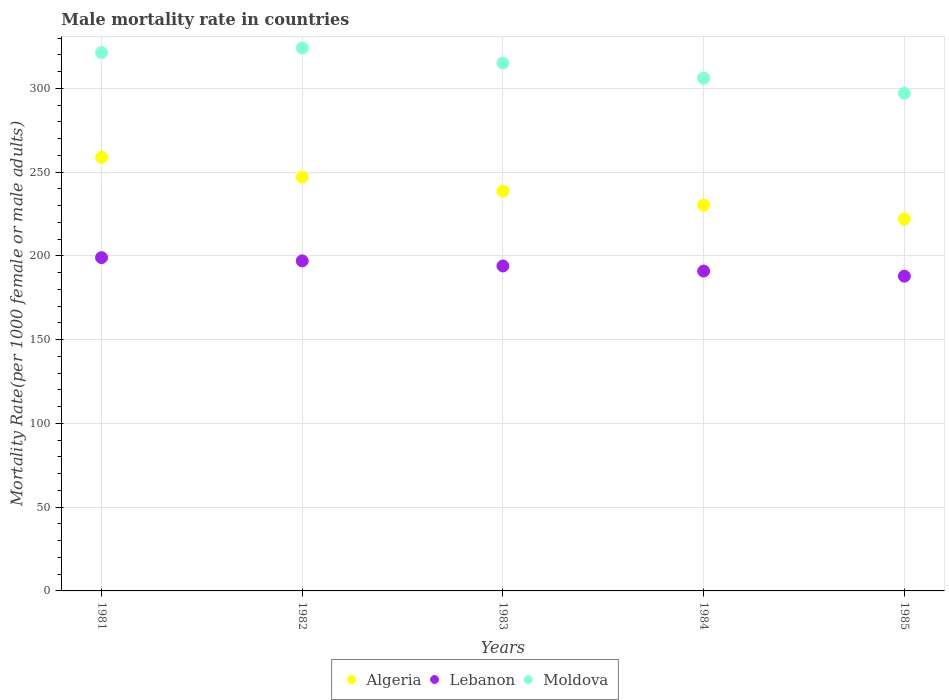How many different coloured dotlines are there?
Make the answer very short. 3. What is the male mortality rate in Moldova in 1983?
Your response must be concise. 315.12. Across all years, what is the maximum male mortality rate in Moldova?
Provide a succinct answer. 324.11. Across all years, what is the minimum male mortality rate in Algeria?
Your answer should be compact. 221.99. In which year was the male mortality rate in Moldova minimum?
Offer a terse response. 1985. What is the total male mortality rate in Algeria in the graph?
Keep it short and to the point. 1196.84. What is the difference between the male mortality rate in Algeria in 1982 and that in 1983?
Your response must be concise. 8.34. What is the difference between the male mortality rate in Algeria in 1985 and the male mortality rate in Moldova in 1981?
Offer a terse response. -99.38. What is the average male mortality rate in Algeria per year?
Your response must be concise. 239.37. In the year 1983, what is the difference between the male mortality rate in Moldova and male mortality rate in Lebanon?
Ensure brevity in your answer.  121.14. What is the ratio of the male mortality rate in Algeria in 1983 to that in 1984?
Your answer should be compact. 1.04. Is the difference between the male mortality rate in Moldova in 1984 and 1985 greater than the difference between the male mortality rate in Lebanon in 1984 and 1985?
Give a very brief answer. Yes. What is the difference between the highest and the second highest male mortality rate in Lebanon?
Offer a very short reply. 1.94. What is the difference between the highest and the lowest male mortality rate in Algeria?
Provide a succinct answer. 36.84. In how many years, is the male mortality rate in Moldova greater than the average male mortality rate in Moldova taken over all years?
Your answer should be compact. 3. Is the sum of the male mortality rate in Algeria in 1981 and 1984 greater than the maximum male mortality rate in Moldova across all years?
Provide a short and direct response. Yes. Is the male mortality rate in Moldova strictly greater than the male mortality rate in Algeria over the years?
Provide a succinct answer. Yes. How many years are there in the graph?
Your response must be concise. 5. Are the values on the major ticks of Y-axis written in scientific E-notation?
Provide a succinct answer. No. Does the graph contain grids?
Offer a terse response. Yes. What is the title of the graph?
Ensure brevity in your answer.  Male mortality rate in countries. Does "Timor-Leste" appear as one of the legend labels in the graph?
Provide a short and direct response. No. What is the label or title of the Y-axis?
Your answer should be very brief. Mortality Rate(per 1000 female or male adults). What is the Mortality Rate(per 1000 female or male adults) of Algeria in 1981?
Offer a terse response. 258.83. What is the Mortality Rate(per 1000 female or male adults) in Lebanon in 1981?
Keep it short and to the point. 198.96. What is the Mortality Rate(per 1000 female or male adults) of Moldova in 1981?
Offer a terse response. 321.38. What is the Mortality Rate(per 1000 female or male adults) of Algeria in 1982?
Give a very brief answer. 247.01. What is the Mortality Rate(per 1000 female or male adults) in Lebanon in 1982?
Offer a very short reply. 197.02. What is the Mortality Rate(per 1000 female or male adults) in Moldova in 1982?
Your response must be concise. 324.11. What is the Mortality Rate(per 1000 female or male adults) of Algeria in 1983?
Provide a short and direct response. 238.67. What is the Mortality Rate(per 1000 female or male adults) in Lebanon in 1983?
Make the answer very short. 193.98. What is the Mortality Rate(per 1000 female or male adults) of Moldova in 1983?
Ensure brevity in your answer.  315.12. What is the Mortality Rate(per 1000 female or male adults) of Algeria in 1984?
Ensure brevity in your answer.  230.33. What is the Mortality Rate(per 1000 female or male adults) of Lebanon in 1984?
Provide a short and direct response. 190.93. What is the Mortality Rate(per 1000 female or male adults) in Moldova in 1984?
Ensure brevity in your answer.  306.13. What is the Mortality Rate(per 1000 female or male adults) in Algeria in 1985?
Your response must be concise. 221.99. What is the Mortality Rate(per 1000 female or male adults) in Lebanon in 1985?
Your response must be concise. 187.89. What is the Mortality Rate(per 1000 female or male adults) in Moldova in 1985?
Your response must be concise. 297.14. Across all years, what is the maximum Mortality Rate(per 1000 female or male adults) in Algeria?
Ensure brevity in your answer.  258.83. Across all years, what is the maximum Mortality Rate(per 1000 female or male adults) in Lebanon?
Your response must be concise. 198.96. Across all years, what is the maximum Mortality Rate(per 1000 female or male adults) of Moldova?
Offer a terse response. 324.11. Across all years, what is the minimum Mortality Rate(per 1000 female or male adults) of Algeria?
Your answer should be very brief. 221.99. Across all years, what is the minimum Mortality Rate(per 1000 female or male adults) of Lebanon?
Provide a succinct answer. 187.89. Across all years, what is the minimum Mortality Rate(per 1000 female or male adults) of Moldova?
Ensure brevity in your answer.  297.14. What is the total Mortality Rate(per 1000 female or male adults) of Algeria in the graph?
Keep it short and to the point. 1196.84. What is the total Mortality Rate(per 1000 female or male adults) of Lebanon in the graph?
Keep it short and to the point. 968.79. What is the total Mortality Rate(per 1000 female or male adults) of Moldova in the graph?
Offer a very short reply. 1563.88. What is the difference between the Mortality Rate(per 1000 female or male adults) of Algeria in 1981 and that in 1982?
Make the answer very short. 11.82. What is the difference between the Mortality Rate(per 1000 female or male adults) of Lebanon in 1981 and that in 1982?
Your response must be concise. 1.94. What is the difference between the Mortality Rate(per 1000 female or male adults) in Moldova in 1981 and that in 1982?
Your answer should be compact. -2.74. What is the difference between the Mortality Rate(per 1000 female or male adults) in Algeria in 1981 and that in 1983?
Your answer should be compact. 20.16. What is the difference between the Mortality Rate(per 1000 female or male adults) of Lebanon in 1981 and that in 1983?
Your answer should be compact. 4.99. What is the difference between the Mortality Rate(per 1000 female or male adults) in Moldova in 1981 and that in 1983?
Make the answer very short. 6.26. What is the difference between the Mortality Rate(per 1000 female or male adults) of Algeria in 1981 and that in 1984?
Offer a very short reply. 28.5. What is the difference between the Mortality Rate(per 1000 female or male adults) of Lebanon in 1981 and that in 1984?
Ensure brevity in your answer.  8.03. What is the difference between the Mortality Rate(per 1000 female or male adults) in Moldova in 1981 and that in 1984?
Make the answer very short. 15.25. What is the difference between the Mortality Rate(per 1000 female or male adults) of Algeria in 1981 and that in 1985?
Provide a short and direct response. 36.84. What is the difference between the Mortality Rate(per 1000 female or male adults) of Lebanon in 1981 and that in 1985?
Your answer should be compact. 11.07. What is the difference between the Mortality Rate(per 1000 female or male adults) of Moldova in 1981 and that in 1985?
Offer a very short reply. 24.24. What is the difference between the Mortality Rate(per 1000 female or male adults) in Algeria in 1982 and that in 1983?
Provide a succinct answer. 8.34. What is the difference between the Mortality Rate(per 1000 female or male adults) in Lebanon in 1982 and that in 1983?
Your response must be concise. 3.04. What is the difference between the Mortality Rate(per 1000 female or male adults) of Moldova in 1982 and that in 1983?
Give a very brief answer. 8.99. What is the difference between the Mortality Rate(per 1000 female or male adults) of Algeria in 1982 and that in 1984?
Provide a short and direct response. 16.68. What is the difference between the Mortality Rate(per 1000 female or male adults) in Lebanon in 1982 and that in 1984?
Offer a very short reply. 6.09. What is the difference between the Mortality Rate(per 1000 female or male adults) in Moldova in 1982 and that in 1984?
Offer a very short reply. 17.98. What is the difference between the Mortality Rate(per 1000 female or male adults) of Algeria in 1982 and that in 1985?
Offer a very short reply. 25.02. What is the difference between the Mortality Rate(per 1000 female or male adults) in Lebanon in 1982 and that in 1985?
Your answer should be compact. 9.13. What is the difference between the Mortality Rate(per 1000 female or male adults) of Moldova in 1982 and that in 1985?
Offer a very short reply. 26.97. What is the difference between the Mortality Rate(per 1000 female or male adults) in Algeria in 1983 and that in 1984?
Keep it short and to the point. 8.34. What is the difference between the Mortality Rate(per 1000 female or male adults) in Lebanon in 1983 and that in 1984?
Offer a very short reply. 3.04. What is the difference between the Mortality Rate(per 1000 female or male adults) in Moldova in 1983 and that in 1984?
Provide a short and direct response. 8.99. What is the difference between the Mortality Rate(per 1000 female or male adults) of Algeria in 1983 and that in 1985?
Offer a terse response. 16.68. What is the difference between the Mortality Rate(per 1000 female or male adults) in Lebanon in 1983 and that in 1985?
Your answer should be very brief. 6.09. What is the difference between the Mortality Rate(per 1000 female or male adults) in Moldova in 1983 and that in 1985?
Your answer should be compact. 17.98. What is the difference between the Mortality Rate(per 1000 female or male adults) of Algeria in 1984 and that in 1985?
Your answer should be very brief. 8.34. What is the difference between the Mortality Rate(per 1000 female or male adults) in Lebanon in 1984 and that in 1985?
Give a very brief answer. 3.04. What is the difference between the Mortality Rate(per 1000 female or male adults) of Moldova in 1984 and that in 1985?
Ensure brevity in your answer.  8.99. What is the difference between the Mortality Rate(per 1000 female or male adults) of Algeria in 1981 and the Mortality Rate(per 1000 female or male adults) of Lebanon in 1982?
Your response must be concise. 61.81. What is the difference between the Mortality Rate(per 1000 female or male adults) of Algeria in 1981 and the Mortality Rate(per 1000 female or male adults) of Moldova in 1982?
Your answer should be very brief. -65.28. What is the difference between the Mortality Rate(per 1000 female or male adults) in Lebanon in 1981 and the Mortality Rate(per 1000 female or male adults) in Moldova in 1982?
Your answer should be compact. -125.15. What is the difference between the Mortality Rate(per 1000 female or male adults) in Algeria in 1981 and the Mortality Rate(per 1000 female or male adults) in Lebanon in 1983?
Make the answer very short. 64.86. What is the difference between the Mortality Rate(per 1000 female or male adults) in Algeria in 1981 and the Mortality Rate(per 1000 female or male adults) in Moldova in 1983?
Provide a succinct answer. -56.29. What is the difference between the Mortality Rate(per 1000 female or male adults) of Lebanon in 1981 and the Mortality Rate(per 1000 female or male adults) of Moldova in 1983?
Give a very brief answer. -116.16. What is the difference between the Mortality Rate(per 1000 female or male adults) in Algeria in 1981 and the Mortality Rate(per 1000 female or male adults) in Lebanon in 1984?
Provide a succinct answer. 67.9. What is the difference between the Mortality Rate(per 1000 female or male adults) of Algeria in 1981 and the Mortality Rate(per 1000 female or male adults) of Moldova in 1984?
Ensure brevity in your answer.  -47.3. What is the difference between the Mortality Rate(per 1000 female or male adults) of Lebanon in 1981 and the Mortality Rate(per 1000 female or male adults) of Moldova in 1984?
Your answer should be compact. -107.17. What is the difference between the Mortality Rate(per 1000 female or male adults) in Algeria in 1981 and the Mortality Rate(per 1000 female or male adults) in Lebanon in 1985?
Your answer should be very brief. 70.94. What is the difference between the Mortality Rate(per 1000 female or male adults) in Algeria in 1981 and the Mortality Rate(per 1000 female or male adults) in Moldova in 1985?
Provide a succinct answer. -38.3. What is the difference between the Mortality Rate(per 1000 female or male adults) in Lebanon in 1981 and the Mortality Rate(per 1000 female or male adults) in Moldova in 1985?
Ensure brevity in your answer.  -98.17. What is the difference between the Mortality Rate(per 1000 female or male adults) of Algeria in 1982 and the Mortality Rate(per 1000 female or male adults) of Lebanon in 1983?
Ensure brevity in your answer.  53.03. What is the difference between the Mortality Rate(per 1000 female or male adults) of Algeria in 1982 and the Mortality Rate(per 1000 female or male adults) of Moldova in 1983?
Provide a short and direct response. -68.11. What is the difference between the Mortality Rate(per 1000 female or male adults) of Lebanon in 1982 and the Mortality Rate(per 1000 female or male adults) of Moldova in 1983?
Provide a short and direct response. -118.1. What is the difference between the Mortality Rate(per 1000 female or male adults) of Algeria in 1982 and the Mortality Rate(per 1000 female or male adults) of Lebanon in 1984?
Give a very brief answer. 56.07. What is the difference between the Mortality Rate(per 1000 female or male adults) of Algeria in 1982 and the Mortality Rate(per 1000 female or male adults) of Moldova in 1984?
Ensure brevity in your answer.  -59.12. What is the difference between the Mortality Rate(per 1000 female or male adults) of Lebanon in 1982 and the Mortality Rate(per 1000 female or male adults) of Moldova in 1984?
Ensure brevity in your answer.  -109.11. What is the difference between the Mortality Rate(per 1000 female or male adults) of Algeria in 1982 and the Mortality Rate(per 1000 female or male adults) of Lebanon in 1985?
Make the answer very short. 59.12. What is the difference between the Mortality Rate(per 1000 female or male adults) in Algeria in 1982 and the Mortality Rate(per 1000 female or male adults) in Moldova in 1985?
Your response must be concise. -50.13. What is the difference between the Mortality Rate(per 1000 female or male adults) of Lebanon in 1982 and the Mortality Rate(per 1000 female or male adults) of Moldova in 1985?
Provide a short and direct response. -100.12. What is the difference between the Mortality Rate(per 1000 female or male adults) of Algeria in 1983 and the Mortality Rate(per 1000 female or male adults) of Lebanon in 1984?
Ensure brevity in your answer.  47.74. What is the difference between the Mortality Rate(per 1000 female or male adults) of Algeria in 1983 and the Mortality Rate(per 1000 female or male adults) of Moldova in 1984?
Your answer should be compact. -67.46. What is the difference between the Mortality Rate(per 1000 female or male adults) of Lebanon in 1983 and the Mortality Rate(per 1000 female or male adults) of Moldova in 1984?
Make the answer very short. -112.15. What is the difference between the Mortality Rate(per 1000 female or male adults) of Algeria in 1983 and the Mortality Rate(per 1000 female or male adults) of Lebanon in 1985?
Your response must be concise. 50.78. What is the difference between the Mortality Rate(per 1000 female or male adults) in Algeria in 1983 and the Mortality Rate(per 1000 female or male adults) in Moldova in 1985?
Ensure brevity in your answer.  -58.47. What is the difference between the Mortality Rate(per 1000 female or male adults) of Lebanon in 1983 and the Mortality Rate(per 1000 female or male adults) of Moldova in 1985?
Offer a terse response. -103.16. What is the difference between the Mortality Rate(per 1000 female or male adults) in Algeria in 1984 and the Mortality Rate(per 1000 female or male adults) in Lebanon in 1985?
Provide a short and direct response. 42.44. What is the difference between the Mortality Rate(per 1000 female or male adults) in Algeria in 1984 and the Mortality Rate(per 1000 female or male adults) in Moldova in 1985?
Your answer should be compact. -66.81. What is the difference between the Mortality Rate(per 1000 female or male adults) in Lebanon in 1984 and the Mortality Rate(per 1000 female or male adults) in Moldova in 1985?
Give a very brief answer. -106.2. What is the average Mortality Rate(per 1000 female or male adults) of Algeria per year?
Your answer should be compact. 239.37. What is the average Mortality Rate(per 1000 female or male adults) of Lebanon per year?
Provide a short and direct response. 193.76. What is the average Mortality Rate(per 1000 female or male adults) of Moldova per year?
Provide a short and direct response. 312.78. In the year 1981, what is the difference between the Mortality Rate(per 1000 female or male adults) of Algeria and Mortality Rate(per 1000 female or male adults) of Lebanon?
Provide a short and direct response. 59.87. In the year 1981, what is the difference between the Mortality Rate(per 1000 female or male adults) of Algeria and Mortality Rate(per 1000 female or male adults) of Moldova?
Ensure brevity in your answer.  -62.54. In the year 1981, what is the difference between the Mortality Rate(per 1000 female or male adults) of Lebanon and Mortality Rate(per 1000 female or male adults) of Moldova?
Keep it short and to the point. -122.41. In the year 1982, what is the difference between the Mortality Rate(per 1000 female or male adults) of Algeria and Mortality Rate(per 1000 female or male adults) of Lebanon?
Provide a succinct answer. 49.99. In the year 1982, what is the difference between the Mortality Rate(per 1000 female or male adults) in Algeria and Mortality Rate(per 1000 female or male adults) in Moldova?
Your answer should be very brief. -77.1. In the year 1982, what is the difference between the Mortality Rate(per 1000 female or male adults) of Lebanon and Mortality Rate(per 1000 female or male adults) of Moldova?
Provide a short and direct response. -127.09. In the year 1983, what is the difference between the Mortality Rate(per 1000 female or male adults) of Algeria and Mortality Rate(per 1000 female or male adults) of Lebanon?
Your answer should be very brief. 44.69. In the year 1983, what is the difference between the Mortality Rate(per 1000 female or male adults) in Algeria and Mortality Rate(per 1000 female or male adults) in Moldova?
Offer a very short reply. -76.45. In the year 1983, what is the difference between the Mortality Rate(per 1000 female or male adults) in Lebanon and Mortality Rate(per 1000 female or male adults) in Moldova?
Keep it short and to the point. -121.14. In the year 1984, what is the difference between the Mortality Rate(per 1000 female or male adults) in Algeria and Mortality Rate(per 1000 female or male adults) in Lebanon?
Offer a very short reply. 39.4. In the year 1984, what is the difference between the Mortality Rate(per 1000 female or male adults) in Algeria and Mortality Rate(per 1000 female or male adults) in Moldova?
Provide a succinct answer. -75.8. In the year 1984, what is the difference between the Mortality Rate(per 1000 female or male adults) of Lebanon and Mortality Rate(per 1000 female or male adults) of Moldova?
Give a very brief answer. -115.2. In the year 1985, what is the difference between the Mortality Rate(per 1000 female or male adults) in Algeria and Mortality Rate(per 1000 female or male adults) in Lebanon?
Keep it short and to the point. 34.1. In the year 1985, what is the difference between the Mortality Rate(per 1000 female or male adults) in Algeria and Mortality Rate(per 1000 female or male adults) in Moldova?
Ensure brevity in your answer.  -75.15. In the year 1985, what is the difference between the Mortality Rate(per 1000 female or male adults) in Lebanon and Mortality Rate(per 1000 female or male adults) in Moldova?
Give a very brief answer. -109.25. What is the ratio of the Mortality Rate(per 1000 female or male adults) of Algeria in 1981 to that in 1982?
Provide a short and direct response. 1.05. What is the ratio of the Mortality Rate(per 1000 female or male adults) in Lebanon in 1981 to that in 1982?
Offer a terse response. 1.01. What is the ratio of the Mortality Rate(per 1000 female or male adults) in Moldova in 1981 to that in 1982?
Offer a very short reply. 0.99. What is the ratio of the Mortality Rate(per 1000 female or male adults) in Algeria in 1981 to that in 1983?
Ensure brevity in your answer.  1.08. What is the ratio of the Mortality Rate(per 1000 female or male adults) in Lebanon in 1981 to that in 1983?
Your answer should be very brief. 1.03. What is the ratio of the Mortality Rate(per 1000 female or male adults) of Moldova in 1981 to that in 1983?
Offer a terse response. 1.02. What is the ratio of the Mortality Rate(per 1000 female or male adults) of Algeria in 1981 to that in 1984?
Your answer should be very brief. 1.12. What is the ratio of the Mortality Rate(per 1000 female or male adults) of Lebanon in 1981 to that in 1984?
Your answer should be very brief. 1.04. What is the ratio of the Mortality Rate(per 1000 female or male adults) of Moldova in 1981 to that in 1984?
Keep it short and to the point. 1.05. What is the ratio of the Mortality Rate(per 1000 female or male adults) of Algeria in 1981 to that in 1985?
Give a very brief answer. 1.17. What is the ratio of the Mortality Rate(per 1000 female or male adults) of Lebanon in 1981 to that in 1985?
Provide a succinct answer. 1.06. What is the ratio of the Mortality Rate(per 1000 female or male adults) in Moldova in 1981 to that in 1985?
Offer a very short reply. 1.08. What is the ratio of the Mortality Rate(per 1000 female or male adults) in Algeria in 1982 to that in 1983?
Give a very brief answer. 1.03. What is the ratio of the Mortality Rate(per 1000 female or male adults) in Lebanon in 1982 to that in 1983?
Your answer should be compact. 1.02. What is the ratio of the Mortality Rate(per 1000 female or male adults) of Moldova in 1982 to that in 1983?
Offer a terse response. 1.03. What is the ratio of the Mortality Rate(per 1000 female or male adults) of Algeria in 1982 to that in 1984?
Give a very brief answer. 1.07. What is the ratio of the Mortality Rate(per 1000 female or male adults) of Lebanon in 1982 to that in 1984?
Your answer should be very brief. 1.03. What is the ratio of the Mortality Rate(per 1000 female or male adults) of Moldova in 1982 to that in 1984?
Give a very brief answer. 1.06. What is the ratio of the Mortality Rate(per 1000 female or male adults) in Algeria in 1982 to that in 1985?
Your answer should be compact. 1.11. What is the ratio of the Mortality Rate(per 1000 female or male adults) of Lebanon in 1982 to that in 1985?
Your answer should be compact. 1.05. What is the ratio of the Mortality Rate(per 1000 female or male adults) in Moldova in 1982 to that in 1985?
Offer a terse response. 1.09. What is the ratio of the Mortality Rate(per 1000 female or male adults) in Algeria in 1983 to that in 1984?
Your response must be concise. 1.04. What is the ratio of the Mortality Rate(per 1000 female or male adults) in Lebanon in 1983 to that in 1984?
Offer a very short reply. 1.02. What is the ratio of the Mortality Rate(per 1000 female or male adults) in Moldova in 1983 to that in 1984?
Provide a succinct answer. 1.03. What is the ratio of the Mortality Rate(per 1000 female or male adults) in Algeria in 1983 to that in 1985?
Provide a succinct answer. 1.08. What is the ratio of the Mortality Rate(per 1000 female or male adults) of Lebanon in 1983 to that in 1985?
Offer a very short reply. 1.03. What is the ratio of the Mortality Rate(per 1000 female or male adults) of Moldova in 1983 to that in 1985?
Make the answer very short. 1.06. What is the ratio of the Mortality Rate(per 1000 female or male adults) of Algeria in 1984 to that in 1985?
Your answer should be very brief. 1.04. What is the ratio of the Mortality Rate(per 1000 female or male adults) in Lebanon in 1984 to that in 1985?
Your response must be concise. 1.02. What is the ratio of the Mortality Rate(per 1000 female or male adults) in Moldova in 1984 to that in 1985?
Ensure brevity in your answer.  1.03. What is the difference between the highest and the second highest Mortality Rate(per 1000 female or male adults) of Algeria?
Offer a very short reply. 11.82. What is the difference between the highest and the second highest Mortality Rate(per 1000 female or male adults) of Lebanon?
Your answer should be compact. 1.94. What is the difference between the highest and the second highest Mortality Rate(per 1000 female or male adults) in Moldova?
Offer a terse response. 2.74. What is the difference between the highest and the lowest Mortality Rate(per 1000 female or male adults) in Algeria?
Provide a short and direct response. 36.84. What is the difference between the highest and the lowest Mortality Rate(per 1000 female or male adults) of Lebanon?
Offer a terse response. 11.07. What is the difference between the highest and the lowest Mortality Rate(per 1000 female or male adults) in Moldova?
Your response must be concise. 26.97. 